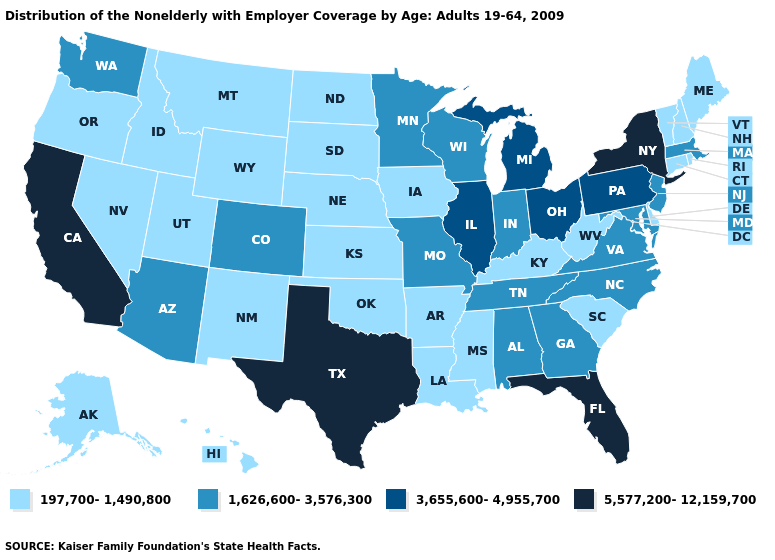Is the legend a continuous bar?
Keep it brief. No. What is the value of Montana?
Short answer required. 197,700-1,490,800. What is the value of Pennsylvania?
Be succinct. 3,655,600-4,955,700. What is the value of Idaho?
Keep it brief. 197,700-1,490,800. Among the states that border Connecticut , does New York have the lowest value?
Short answer required. No. Which states hav the highest value in the West?
Keep it brief. California. What is the value of Florida?
Answer briefly. 5,577,200-12,159,700. How many symbols are there in the legend?
Keep it brief. 4. What is the value of Tennessee?
Write a very short answer. 1,626,600-3,576,300. What is the lowest value in states that border Michigan?
Short answer required. 1,626,600-3,576,300. What is the value of Wisconsin?
Write a very short answer. 1,626,600-3,576,300. How many symbols are there in the legend?
Give a very brief answer. 4. Is the legend a continuous bar?
Give a very brief answer. No. Name the states that have a value in the range 1,626,600-3,576,300?
Be succinct. Alabama, Arizona, Colorado, Georgia, Indiana, Maryland, Massachusetts, Minnesota, Missouri, New Jersey, North Carolina, Tennessee, Virginia, Washington, Wisconsin. What is the highest value in states that border Mississippi?
Quick response, please. 1,626,600-3,576,300. 